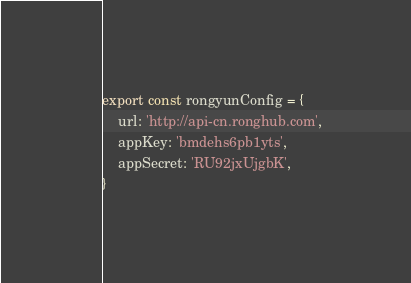Convert code to text. <code><loc_0><loc_0><loc_500><loc_500><_TypeScript_>export const rongyunConfig = {
    url: 'http://api-cn.ronghub.com',
    appKey: 'bmdehs6pb1yts',
    appSecret: 'RU92jxUjgbK',
}</code> 